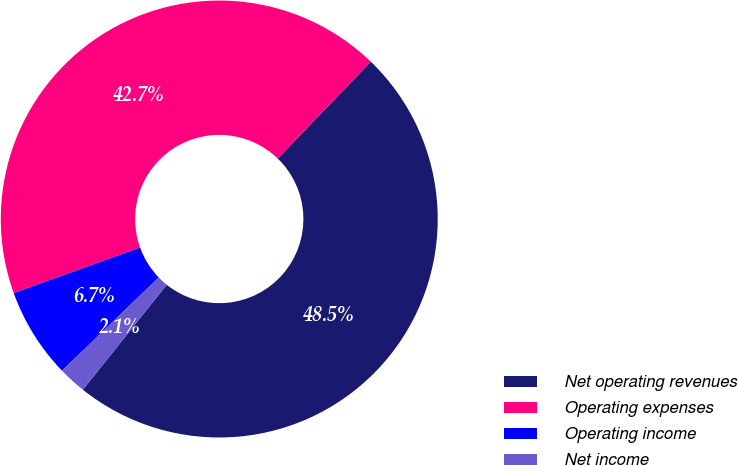<chart> <loc_0><loc_0><loc_500><loc_500><pie_chart><fcel>Net operating revenues<fcel>Operating expenses<fcel>Operating income<fcel>Net income<nl><fcel>48.53%<fcel>42.7%<fcel>6.71%<fcel>2.06%<nl></chart> 